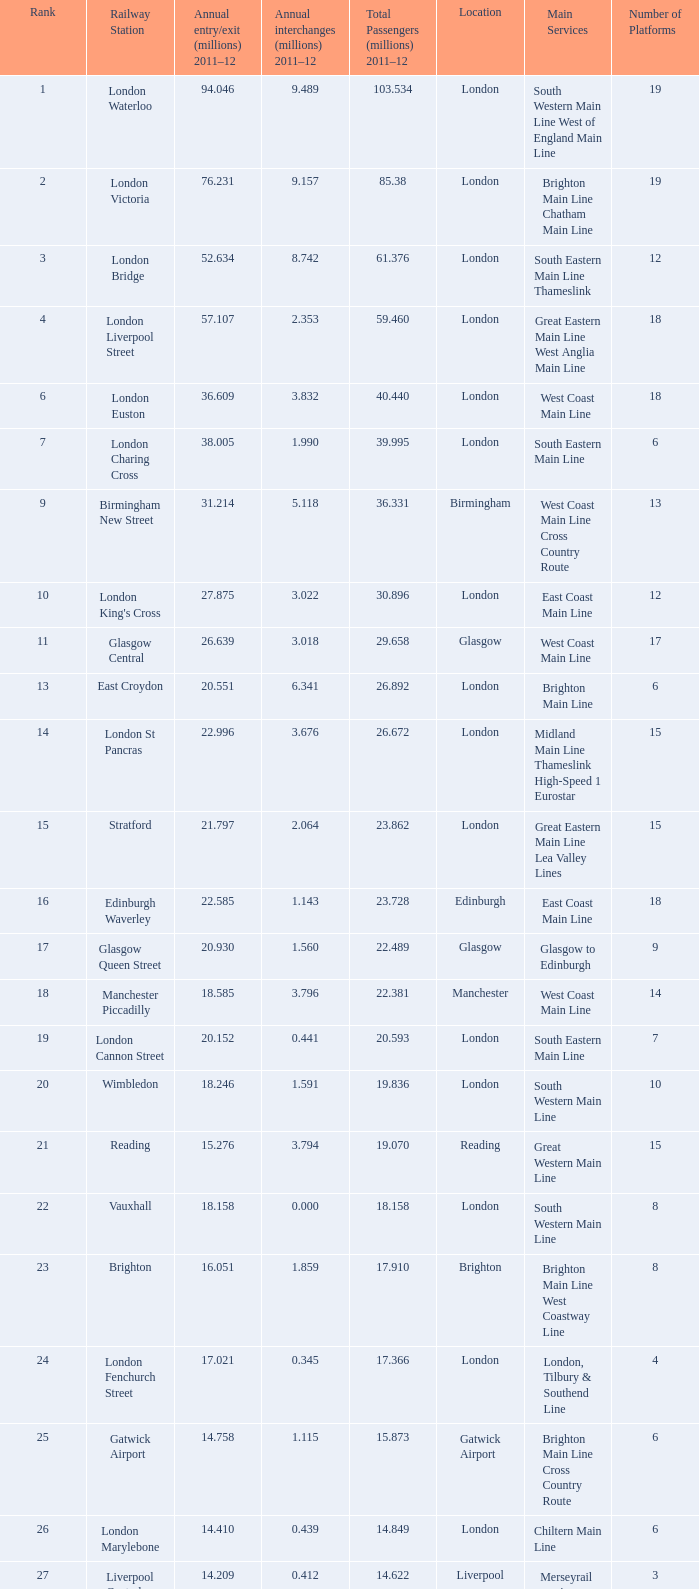What is the lowest rank of Gatwick Airport?  25.0. 